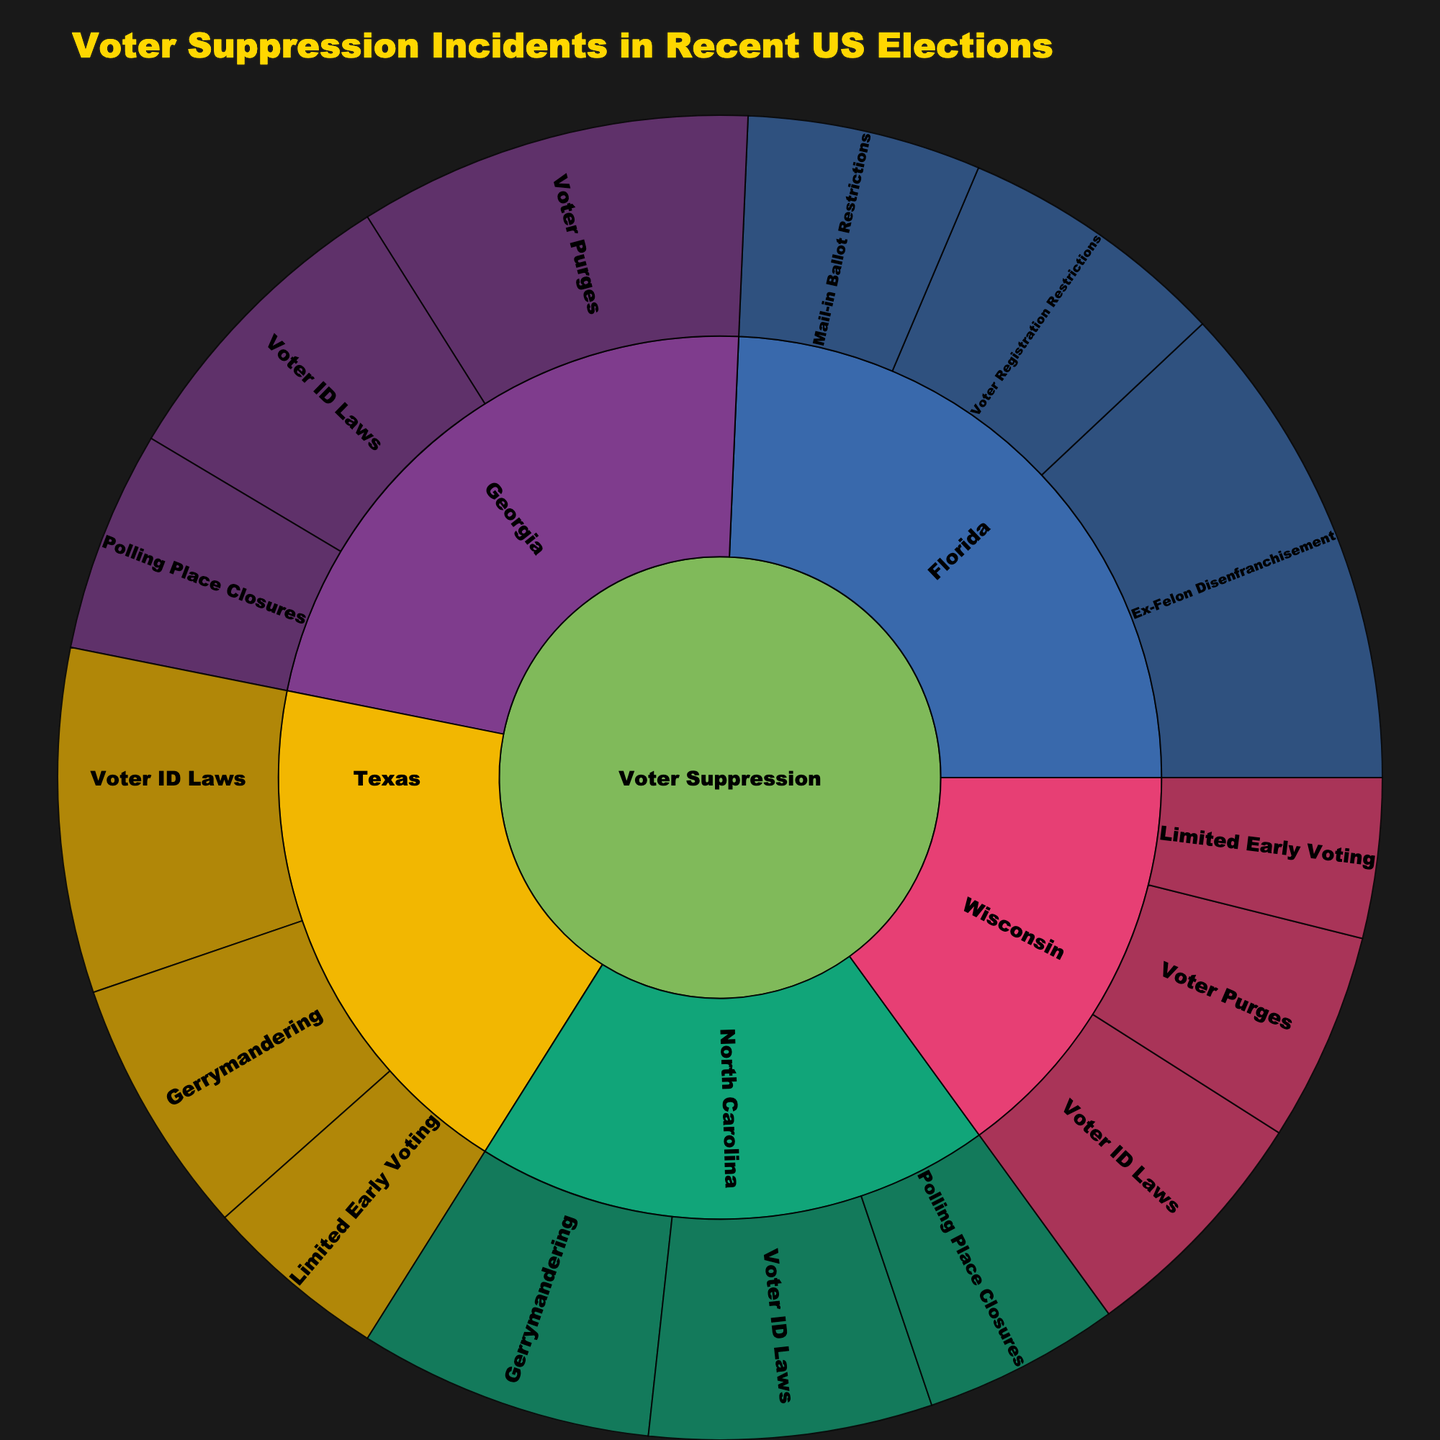What is the total number of voter suppression incidents reported in Georgia? To find the total number of voter suppression incidents reported in Georgia, add the counts for each method: Voter ID Laws (250), Polling Place Closures (180), and Voter Purges (320). Calculation: 250 + 180 + 320 = 750.
Answer: 750 Which state has the highest number of incidents related to Ex-Felon Disenfranchisement? To find the state with the highest number of incidents of Ex-Felon Disenfranchisement, locate the corresponding category in the sunburst plot. Florida shows 400 incidents related to Ex-Felon Disenfranchisement, which is the highest among all states.
Answer: Florida What is the difference in the number of voter suppression incidents between Texas and North Carolina? To find the difference, first sum the counts for all methods in each state. For Texas: Voter ID Laws (280) + Gerrymandering (210) + Limited Early Voting (150). Calculation: 280 + 210 + 150 = 640. For North Carolina: Voter ID Laws (230) + Polling Place Closures (160) + Gerrymandering (240). Calculation: 230 + 160 + 240 = 630. Difference: 640 - 630 = 10.
Answer: 10 Which method of suppression has the highest number of incidents in Wisconsin? To determine this, look at the counts for each method in Wisconsin. Voter ID Laws: 200, Voter Purges: 170, Limited Early Voting: 130. Voter ID Laws has the highest number of incidents (200).
Answer: Voter ID Laws How many more incidents of Voter ID Laws are reported in Texas compared to Wisconsin? Compare the counts of Voter ID Laws incidents in both states. Texas: 280, Wisconsin: 200. Difference: 280 - 200 = 80.
Answer: 80 What is the total count of voter suppression incidents involving Voter ID Laws across all states? Add the counts of Voter ID Laws incidents from each state: Georgia (250), Texas (280), North Carolina (230), Wisconsin (200). Calculation: 250 + 280 + 230 + 200 = 960.
Answer: 960 Which state has the least number of overall voter suppression incidents, and what is that number? To find the state with the least incidents, sum counts for all methods in each state and compare. Wisconsin has the counts: Voter ID Laws (200), Voter Purges (170), Limited Early Voting (130). Total: 200 + 170 + 130 = 500. This is the smallest total compared to other states.
Answer: Wisconsin, 500 What is the ratio of incidents involving Polling Place Closures in Georgia to those in North Carolina? First, find the counts for Polling Place Closures in both states: Georgia (180), North Carolina (160). Then, calculate the ratio by dividing the two counts. Ratio: 180 / 160 = 1.125.
Answer: 1.125 